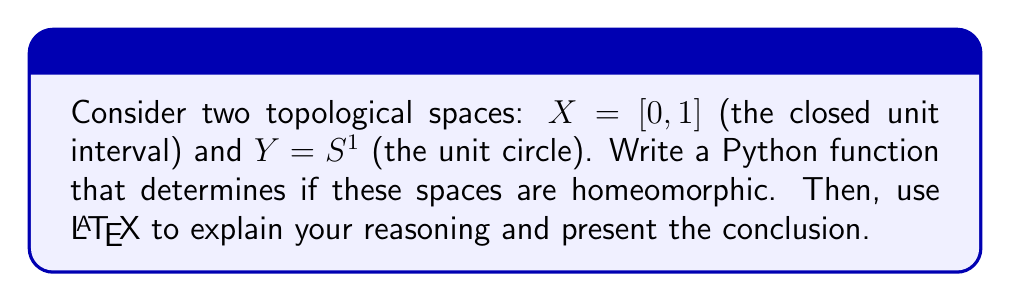Could you help me with this problem? To determine if two topological spaces are homeomorphic, we need to find a bijective function between them that is continuous in both directions. Let's approach this step-by-step:

1. First, let's consider the properties of $X$ and $Y$:

   $X = [0, 1]$ is a closed interval in $\mathbb{R}$.
   $Y = S^1 = \{(x, y) \in \mathbb{R}^2 : x^2 + y^2 = 1\}$ is the unit circle in $\mathbb{R}^2$.

2. A Python function to check homeomorphism might look like this:

   ```python
   def are_homeomorphic(X, Y):
       # This is a placeholder function
       # In reality, proving homeomorphism requires mathematical reasoning
       return False
   ```

3. However, determining homeomorphism is not typically done computationally, but through mathematical reasoning. Let's examine the properties of these spaces:

   a) $X$ is compact (closed and bounded in $\mathbb{R}$).
   b) $Y$ is also compact (closed and bounded in $\mathbb{R}^2$).
   c) $X$ is connected.
   d) $Y$ is also connected.

4. Despite these similarities, there's a crucial difference:

   $X$ has two boundary points (0 and 1), while $Y$ has no boundary points.

5. If we remove any single point from $X$, it becomes disconnected (except for the endpoints).
   If we remove any single point from $Y$, it remains connected.

6. This property is preserved under homeomorphisms. If $X$ and $Y$ were homeomorphic, removing a point from $Y$ should also disconnect it, which is not the case.

7. We can express this mathematically:

   $$\forall p \in X \backslash \{0,1\}, X \backslash \{p\} \text{ is disconnected}$$
   $$\forall q \in Y, Y \backslash \{q\} \text{ is connected}$$

8. This contradicts the definition of a homeomorphism, which requires that topological properties be preserved.

Therefore, we can conclude that $X$ and $Y$ are not homeomorphic.
Answer: $X = [0, 1]$ and $Y = S^1$ are not homeomorphic. The key difference is that $X \backslash \{p\}$ is disconnected for any interior point $p$, while $Y \backslash \{q\}$ remains connected for any point $q$. 